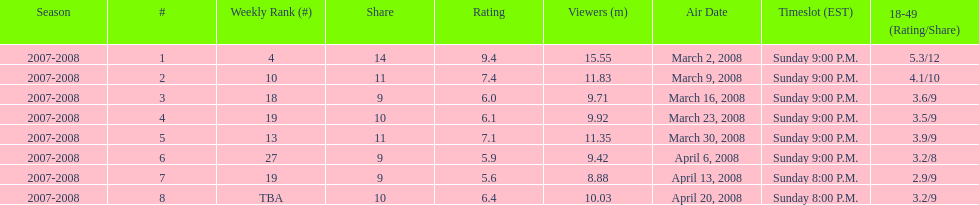Which air date had the least viewers? April 13, 2008. 